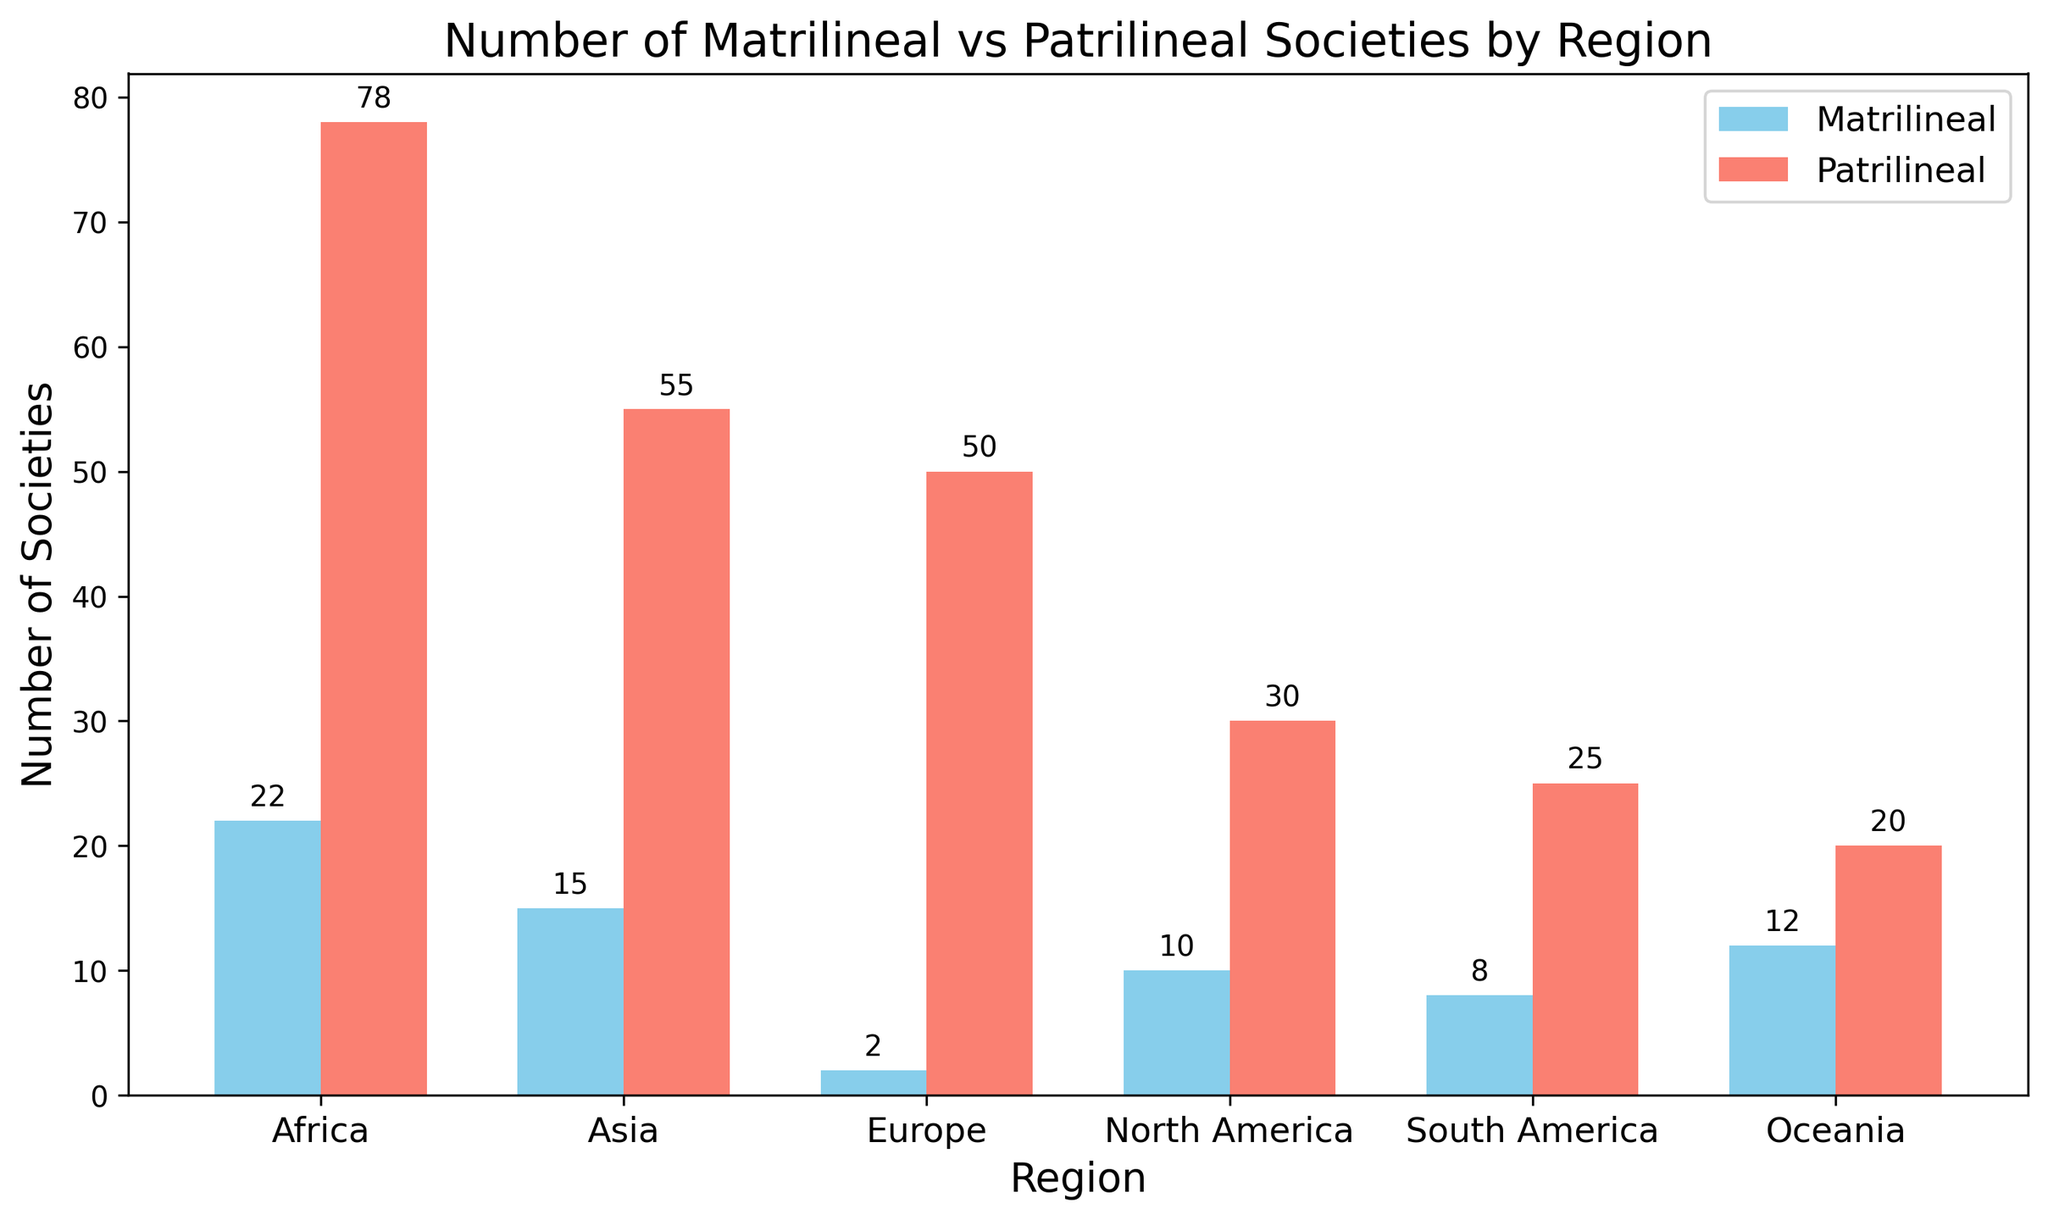Which region has the highest number of patrilineal societies? By looking at the bar heights, identify the tallest bar in the Patrilineal category. The tallest bar corresponds to the region with the highest number.
Answer: Africa Which region has more matrilineal societies, Oceania or North America? Compare the heights of the Matrilineal bars for Oceania and North America. Oceania has a higher bar.
Answer: Oceania How many more patrilineal societies are there in Asia compared to Europe? Subtract the number of patrilineal societies in Europe from the number in Asia. Asia: 55, Europe: 50, so 55 - 50.
Answer: 5 What is the total number of matrilineal societies in all regions? Add the values of Matrilineal societies for all regions: 22 + 15 + 2 + 10 + 8 + 12.
Answer: 69 In which region is the difference between matrilineal and patrilineal societies highest? For each region, subtract the number of matrilineal societies from the number of patrilineal societies and find the maximum value. Africa: 78-22=56, Asia: 55-15=40, Europe: 50-2=48, North America: 30-10=20, South America: 25-8=17, Oceania: 20-12=8. Highest difference is in Africa.
Answer: Africa Do any regions have an equal number of matrilineal and patrilineal societies? Check if any pairs of bars (one from Matrilineal and one from Patrilineal) are of equal height. None are equal.
Answer: No What is the average number of patrilineal societies across all regions? Sum the Patrilineal values and divide by the number of regions: (78 + 55 + 50 + 30 + 25 + 20) / 6 = 258 / 6.
Answer: 43 Which region has the smallest number of matrilineal societies? Identify the shortest bar in the Matrilineal category. That bar corresponds to the region with the smallest number.
Answer: Europe 